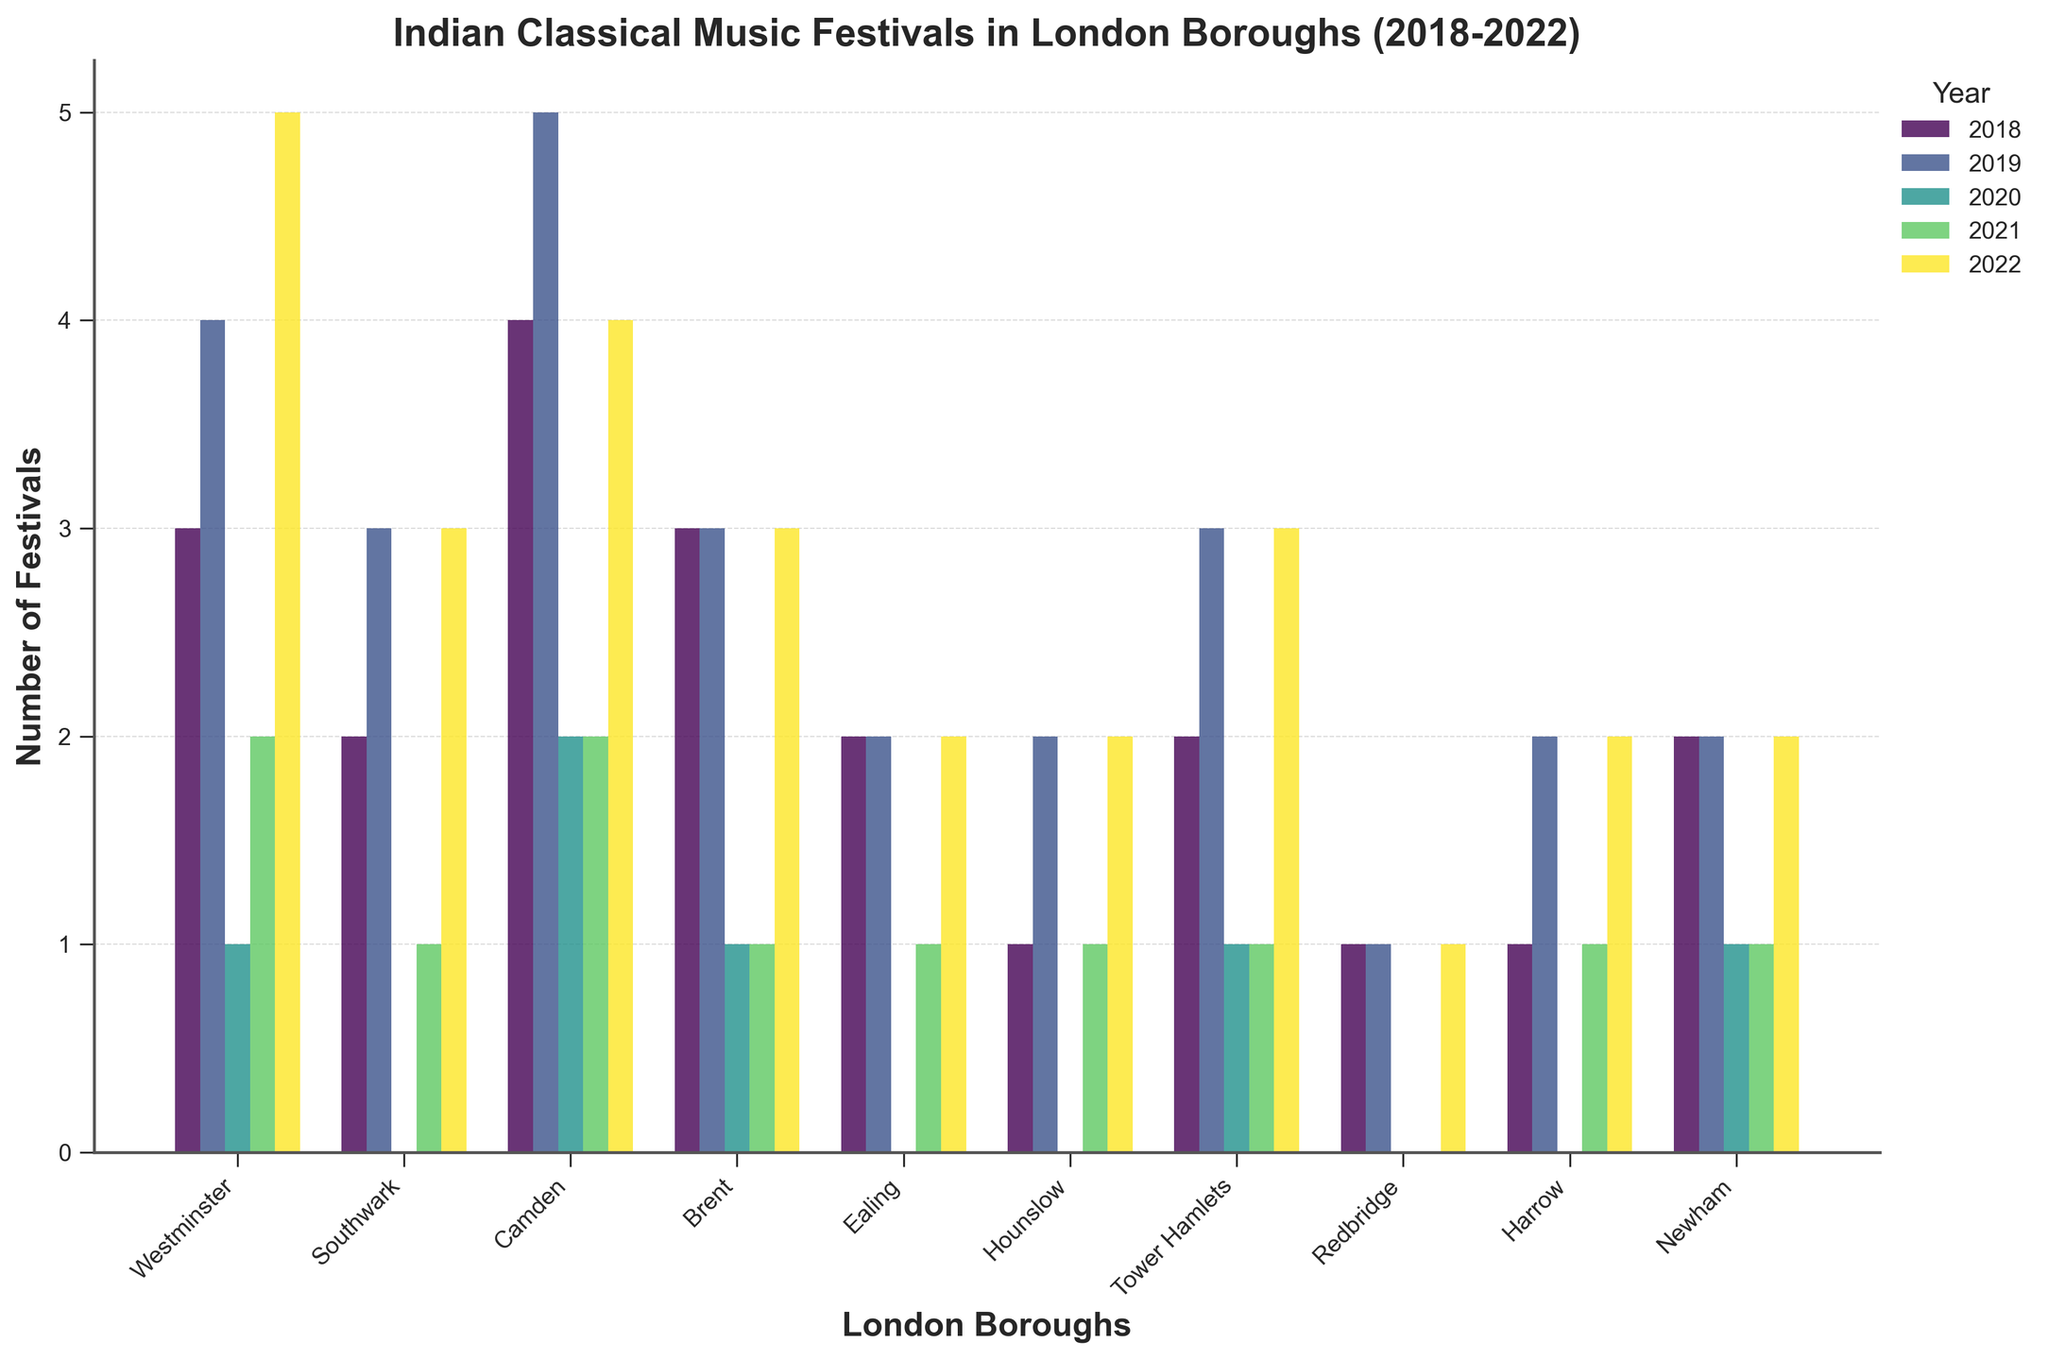Which borough held the highest number of Indian classical music festivals in 2022? Look at the year 2022 and compare the heights of the bars for each borough. The tallest bar in 2022 is for Westminster with 5 festivals.
Answer: Westminster Which boroughs held no festivals in the year 2020? Examine the bars for each borough in the year 2020. Those without a bar in that year are Camden, Ealing, Hounslow, Southwark, Redbridge, Harrow.
Answer: Camden, Ealing, Hounslow, Southwark, Redbridge, Harrow What is the total number of festivals held in Camden over the past 5 years? Sum the number of festivals held in Camden from 2018 to 2022: 4 + 5 + 2 + 2 + 4 = 17.
Answer: 17 Which borough has shown a consistent increase in the number of festivals from 2018 to 2022? Review the trend for each borough from 2018 to 2022. None of the boroughs show a consistent increase, as all of them have at least one year where the count decreases or remains the same.
Answer: None How many more festivals were held in Westminster in 2019 compared to 2020? Subtract the number of festivals in 2020 from the number in 2019 for Westminster: 4 - 1 = 3.
Answer: 3 Which borough had the most festivals in 2019? Compare the heights of the bars for the year 2019. Camden had the highest bar with 5 festivals in that year.
Answer: Camden Which boroughs had the same number of festivals in 2021 and 2022? Look at the bars for each borough in 2021 and 2022 and compare. Ealing, Hounslow, Harrow, and Newham each had 1 festival in 2021 and 2 in 2022, which is not the same. So, no borough had the same number of festivals.
Answer: None What is the average number of festivals held per year in Tower Hamlets from 2018 to 2022? Sum the number of festivals held in Tower Hamlets from 2018 to 2022: 2 + 3 + 1 + 1 + 3 = 10. Divide by 5 (number of years): 10 / 5 = 2.
Answer: 2 Which year had the lowest total number of festivals across all boroughs? Sum the festivals for each year and compare: 
2018: 21,
2019: 25,
2020: 6,
2021: 10,
2022: 25. 
2020 had the lowest total with 6 festivals.
Answer: 2020 